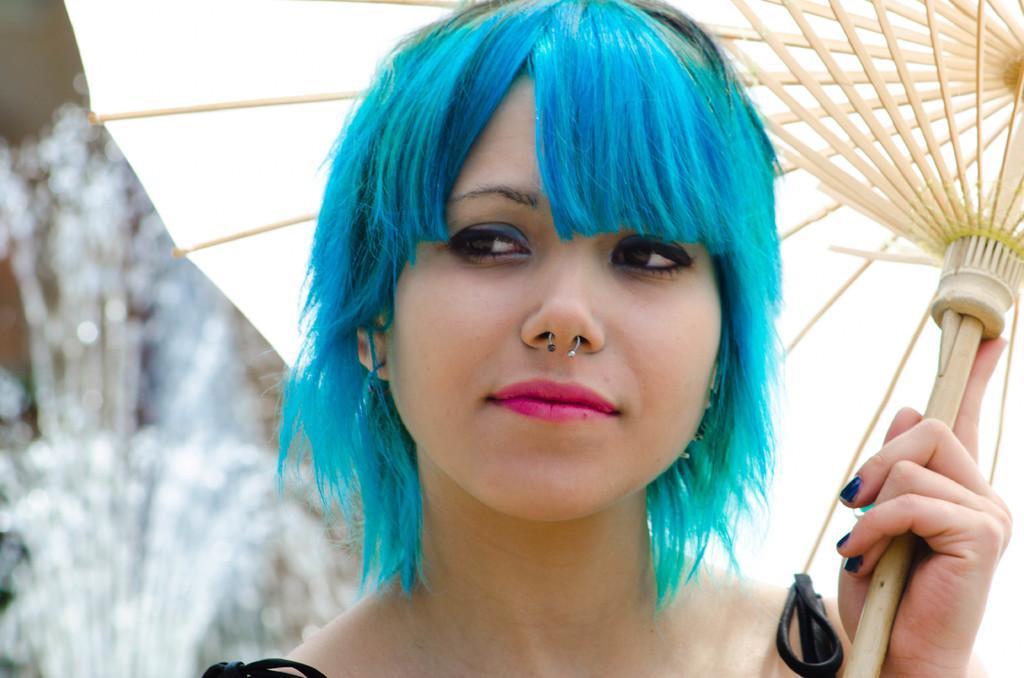Describe this image in one or two sentences. There is a person with blue hair and holding umbrella. Background it is blur. 